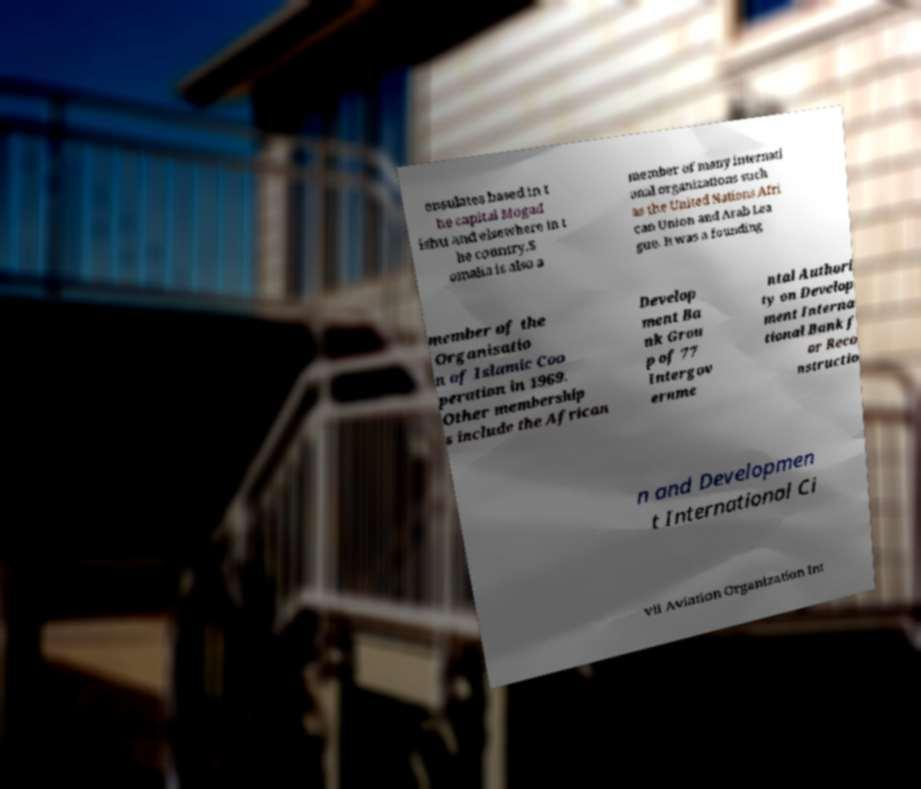Could you assist in decoding the text presented in this image and type it out clearly? onsulates based in t he capital Mogad ishu and elsewhere in t he country.S omalia is also a member of many internati onal organizations such as the United Nations Afri can Union and Arab Lea gue. It was a founding member of the Organisatio n of Islamic Coo peration in 1969. Other membership s include the African Develop ment Ba nk Grou p of 77 Intergov ernme ntal Authori ty on Develop ment Interna tional Bank f or Reco nstructio n and Developmen t International Ci vil Aviation Organization Int 